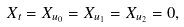<formula> <loc_0><loc_0><loc_500><loc_500>X _ { t } = X _ { u _ { 0 } } = X _ { u _ { 1 } } = X _ { u _ { 2 } } = 0 ,</formula> 